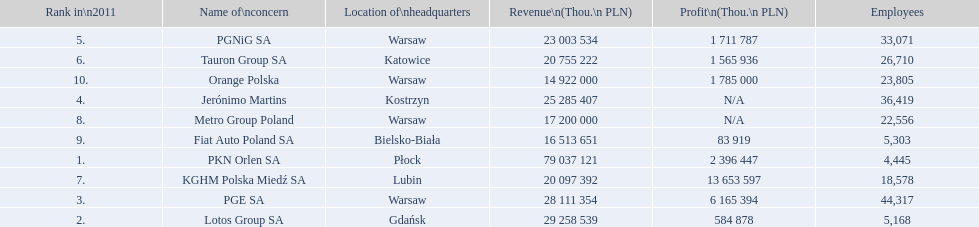Parse the table in full. {'header': ['Rank in\\n2011', 'Name of\\nconcern', 'Location of\\nheadquarters', 'Revenue\\n(Thou.\\n\xa0PLN)', 'Profit\\n(Thou.\\n\xa0PLN)', 'Employees'], 'rows': [['5.', 'PGNiG SA', 'Warsaw', '23 003 534', '1 711 787', '33,071'], ['6.', 'Tauron Group SA', 'Katowice', '20 755 222', '1 565 936', '26,710'], ['10.', 'Orange Polska', 'Warsaw', '14 922 000', '1 785 000', '23,805'], ['4.', 'Jerónimo Martins', 'Kostrzyn', '25 285 407', 'N/A', '36,419'], ['8.', 'Metro Group Poland', 'Warsaw', '17 200 000', 'N/A', '22,556'], ['9.', 'Fiat Auto Poland SA', 'Bielsko-Biała', '16 513 651', '83 919', '5,303'], ['1.', 'PKN Orlen SA', 'Płock', '79 037 121', '2 396 447', '4,445'], ['7.', 'KGHM Polska Miedź SA', 'Lubin', '20 097 392', '13 653 597', '18,578'], ['3.', 'PGE SA', 'Warsaw', '28 111 354', '6 165 394', '44,317'], ['2.', 'Lotos Group SA', 'Gdańsk', '29 258 539', '584 878', '5,168']]} Which company had the least revenue? Orange Polska. 